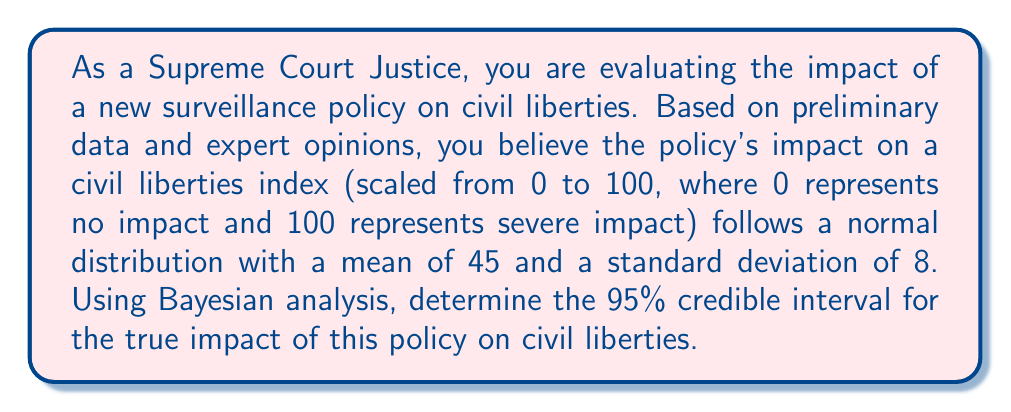Give your solution to this math problem. To solve this problem, we'll use the properties of the normal distribution and the concept of credible intervals in Bayesian statistics.

1) In Bayesian statistics, when we have a normal prior distribution and are estimating a population mean, the posterior distribution is also normal.

2) Given:
   - The impact follows a normal distribution
   - Prior mean (μ) = 45
   - Prior standard deviation (σ) = 8
   - We want a 95% credible interval

3) For a normal distribution, the 95% credible interval is approximately μ ± 1.96σ.

4) Calculate the lower bound of the credible interval:
   $$ \text{Lower Bound} = \mu - 1.96\sigma = 45 - 1.96(8) = 45 - 15.68 = 29.32 $$

5) Calculate the upper bound of the credible interval:
   $$ \text{Upper Bound} = \mu + 1.96\sigma = 45 + 1.96(8) = 45 + 15.68 = 60.68 $$

6) Round the results to two decimal places for practicality.

Therefore, we can be 95% confident that the true impact of the policy on the civil liberties index lies between 29.32 and 60.68.
Answer: The 95% credible interval for the impact of the new surveillance policy on civil liberties is [29.32, 60.68] on the civil liberties impact index. 